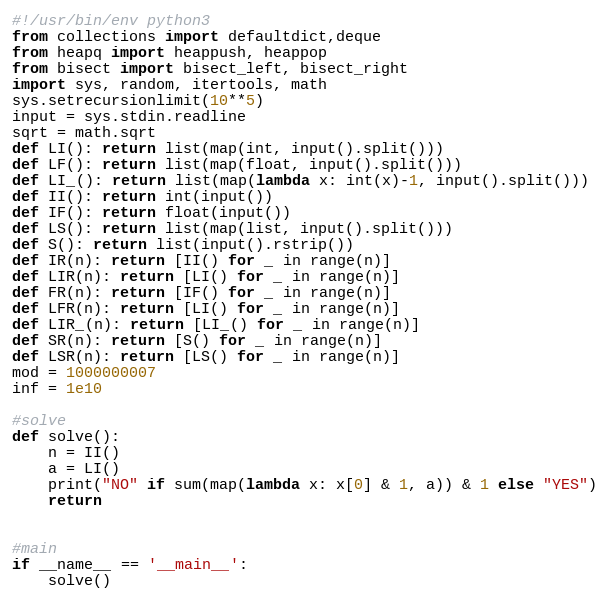Convert code to text. <code><loc_0><loc_0><loc_500><loc_500><_Python_>#!/usr/bin/env python3
from collections import defaultdict,deque
from heapq import heappush, heappop
from bisect import bisect_left, bisect_right
import sys, random, itertools, math
sys.setrecursionlimit(10**5)
input = sys.stdin.readline
sqrt = math.sqrt
def LI(): return list(map(int, input().split()))
def LF(): return list(map(float, input().split()))
def LI_(): return list(map(lambda x: int(x)-1, input().split()))
def II(): return int(input())
def IF(): return float(input())
def LS(): return list(map(list, input().split()))
def S(): return list(input().rstrip())
def IR(n): return [II() for _ in range(n)]
def LIR(n): return [LI() for _ in range(n)]
def FR(n): return [IF() for _ in range(n)]
def LFR(n): return [LI() for _ in range(n)]
def LIR_(n): return [LI_() for _ in range(n)]
def SR(n): return [S() for _ in range(n)]
def LSR(n): return [LS() for _ in range(n)]
mod = 1000000007
inf = 1e10

#solve
def solve():
    n = II()
    a = LI()
    print("NO" if sum(map(lambda x: x[0] & 1, a)) & 1 else "YES")
    return


#main
if __name__ == '__main__':
    solve()
</code> 